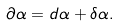Convert formula to latex. <formula><loc_0><loc_0><loc_500><loc_500>\text { } \partial \alpha = d \alpha + \delta \alpha .</formula> 